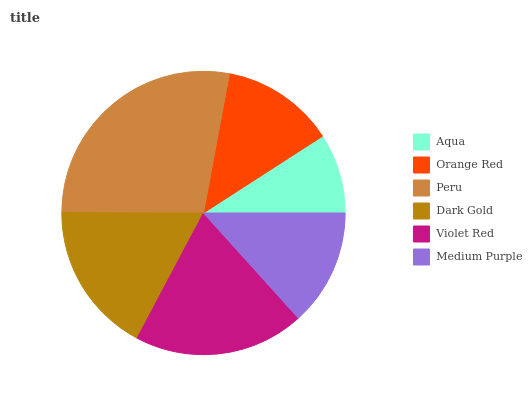Is Aqua the minimum?
Answer yes or no. Yes. Is Peru the maximum?
Answer yes or no. Yes. Is Orange Red the minimum?
Answer yes or no. No. Is Orange Red the maximum?
Answer yes or no. No. Is Orange Red greater than Aqua?
Answer yes or no. Yes. Is Aqua less than Orange Red?
Answer yes or no. Yes. Is Aqua greater than Orange Red?
Answer yes or no. No. Is Orange Red less than Aqua?
Answer yes or no. No. Is Dark Gold the high median?
Answer yes or no. Yes. Is Medium Purple the low median?
Answer yes or no. Yes. Is Orange Red the high median?
Answer yes or no. No. Is Violet Red the low median?
Answer yes or no. No. 